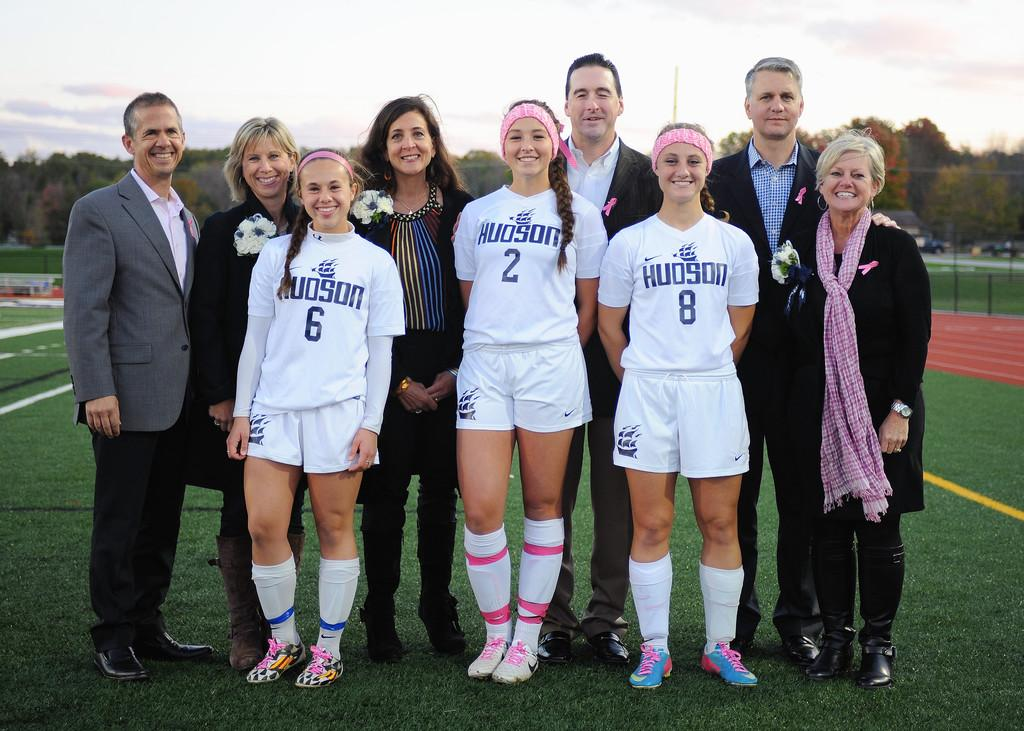<image>
Share a concise interpretation of the image provided. Group of people getting their picture taken with 3 of them soccer players, wearing Hudson jerseys #6, #2, and #8. 